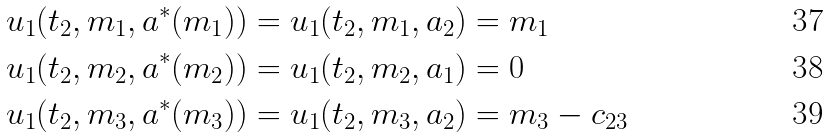Convert formula to latex. <formula><loc_0><loc_0><loc_500><loc_500>& u _ { 1 } ( t _ { 2 } , m _ { 1 } , a ^ { * } ( m _ { 1 } ) ) = u _ { 1 } ( t _ { 2 } , m _ { 1 } , a _ { 2 } ) = m _ { 1 } \\ & u _ { 1 } ( t _ { 2 } , m _ { 2 } , a ^ { * } ( m _ { 2 } ) ) = u _ { 1 } ( t _ { 2 } , m _ { 2 } , a _ { 1 } ) = 0 \\ & u _ { 1 } ( t _ { 2 } , m _ { 3 } , a ^ { * } ( m _ { 3 } ) ) = u _ { 1 } ( t _ { 2 } , m _ { 3 } , a _ { 2 } ) = m _ { 3 } - c _ { 2 3 }</formula> 